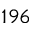Convert formula to latex. <formula><loc_0><loc_0><loc_500><loc_500>1 9 6</formula> 